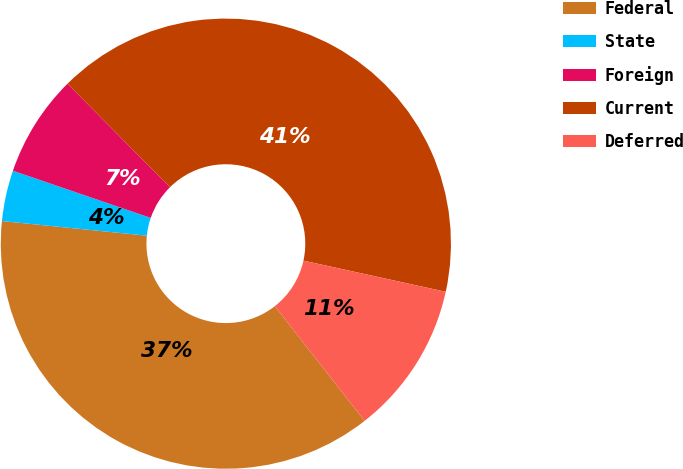Convert chart to OTSL. <chart><loc_0><loc_0><loc_500><loc_500><pie_chart><fcel>Federal<fcel>State<fcel>Foreign<fcel>Current<fcel>Deferred<nl><fcel>37.17%<fcel>3.65%<fcel>7.33%<fcel>40.85%<fcel>11.0%<nl></chart> 